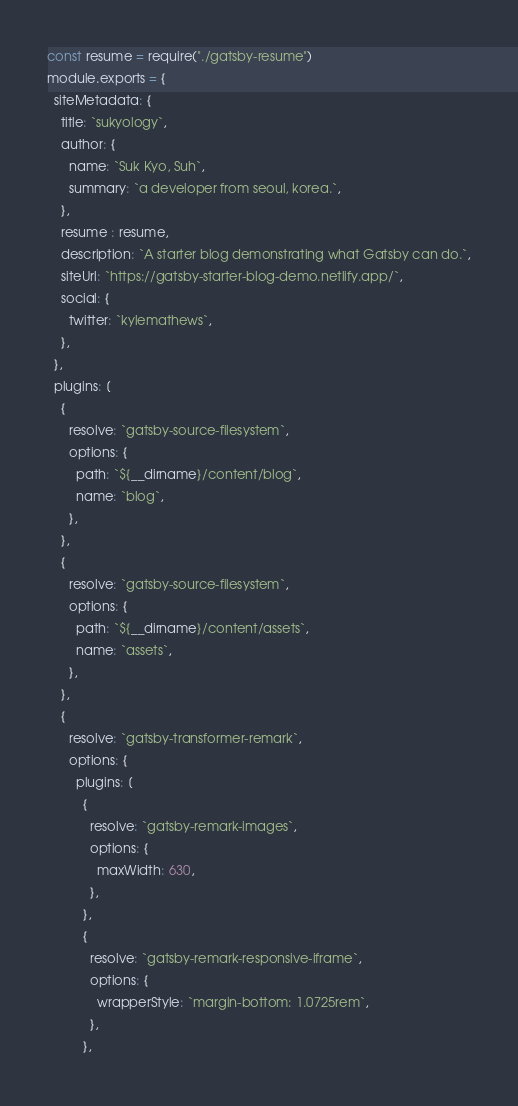<code> <loc_0><loc_0><loc_500><loc_500><_JavaScript_>const resume = require("./gatsby-resume")
module.exports = {
  siteMetadata: {
    title: `sukyology`,
    author: {
      name: `Suk Kyo, Suh`,
      summary: `a developer from seoul, korea.`,
    },
    resume : resume,
    description: `A starter blog demonstrating what Gatsby can do.`,
    siteUrl: `https://gatsby-starter-blog-demo.netlify.app/`,
    social: {
      twitter: `kylemathews`,
    },
  },
  plugins: [
    {
      resolve: `gatsby-source-filesystem`,
      options: {
        path: `${__dirname}/content/blog`,
        name: `blog`,
      },
    },
    {
      resolve: `gatsby-source-filesystem`,
      options: {
        path: `${__dirname}/content/assets`,
        name: `assets`,
      },
    },
    {
      resolve: `gatsby-transformer-remark`,
      options: {
        plugins: [
          {
            resolve: `gatsby-remark-images`,
            options: {
              maxWidth: 630,
            },
          },
          {
            resolve: `gatsby-remark-responsive-iframe`,
            options: {
              wrapperStyle: `margin-bottom: 1.0725rem`,
            },
          },</code> 